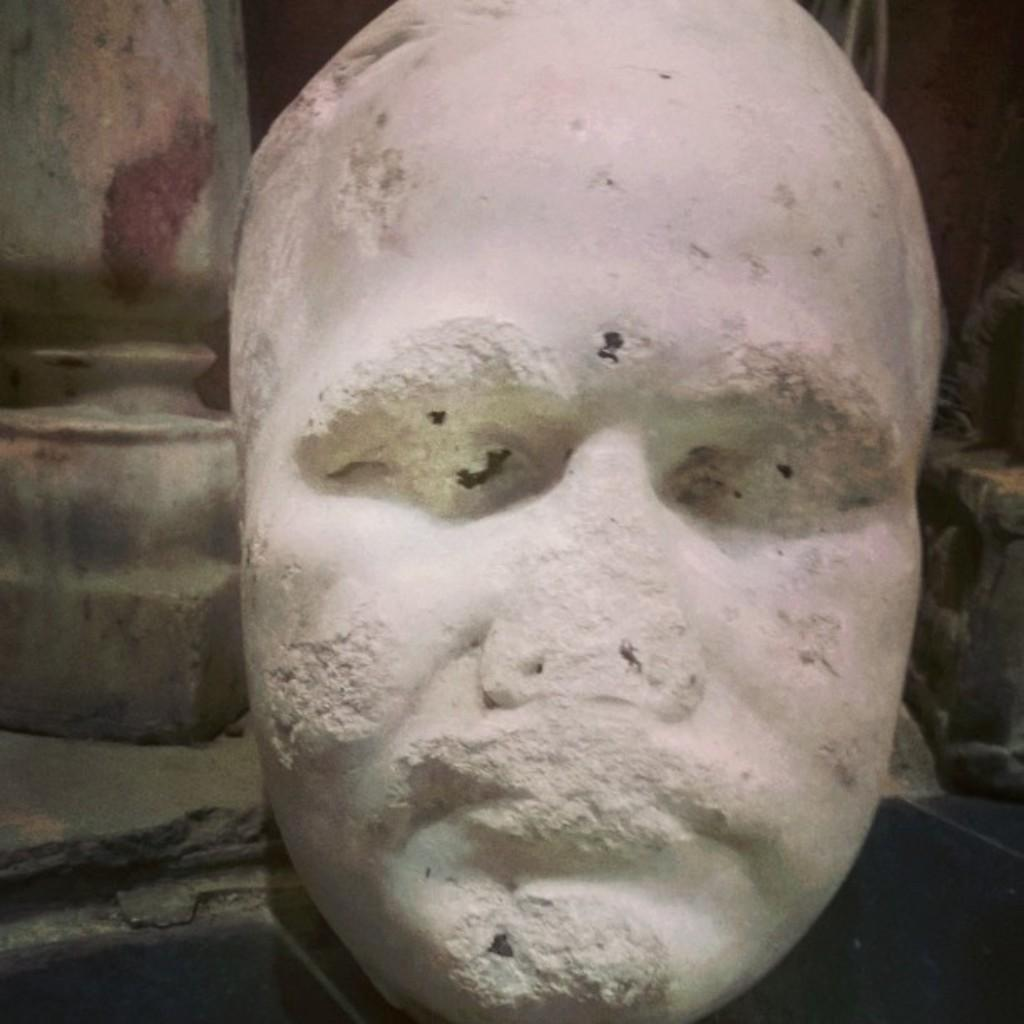What is the main subject in the center of the image? There is a sculpture in the center of the image. What can be seen in the background of the image? There is a wall in the background of the image. What type of stick is being used to create shade in the image? There is no stick or shade present in the image; it only features a sculpture and a wall in the background. 